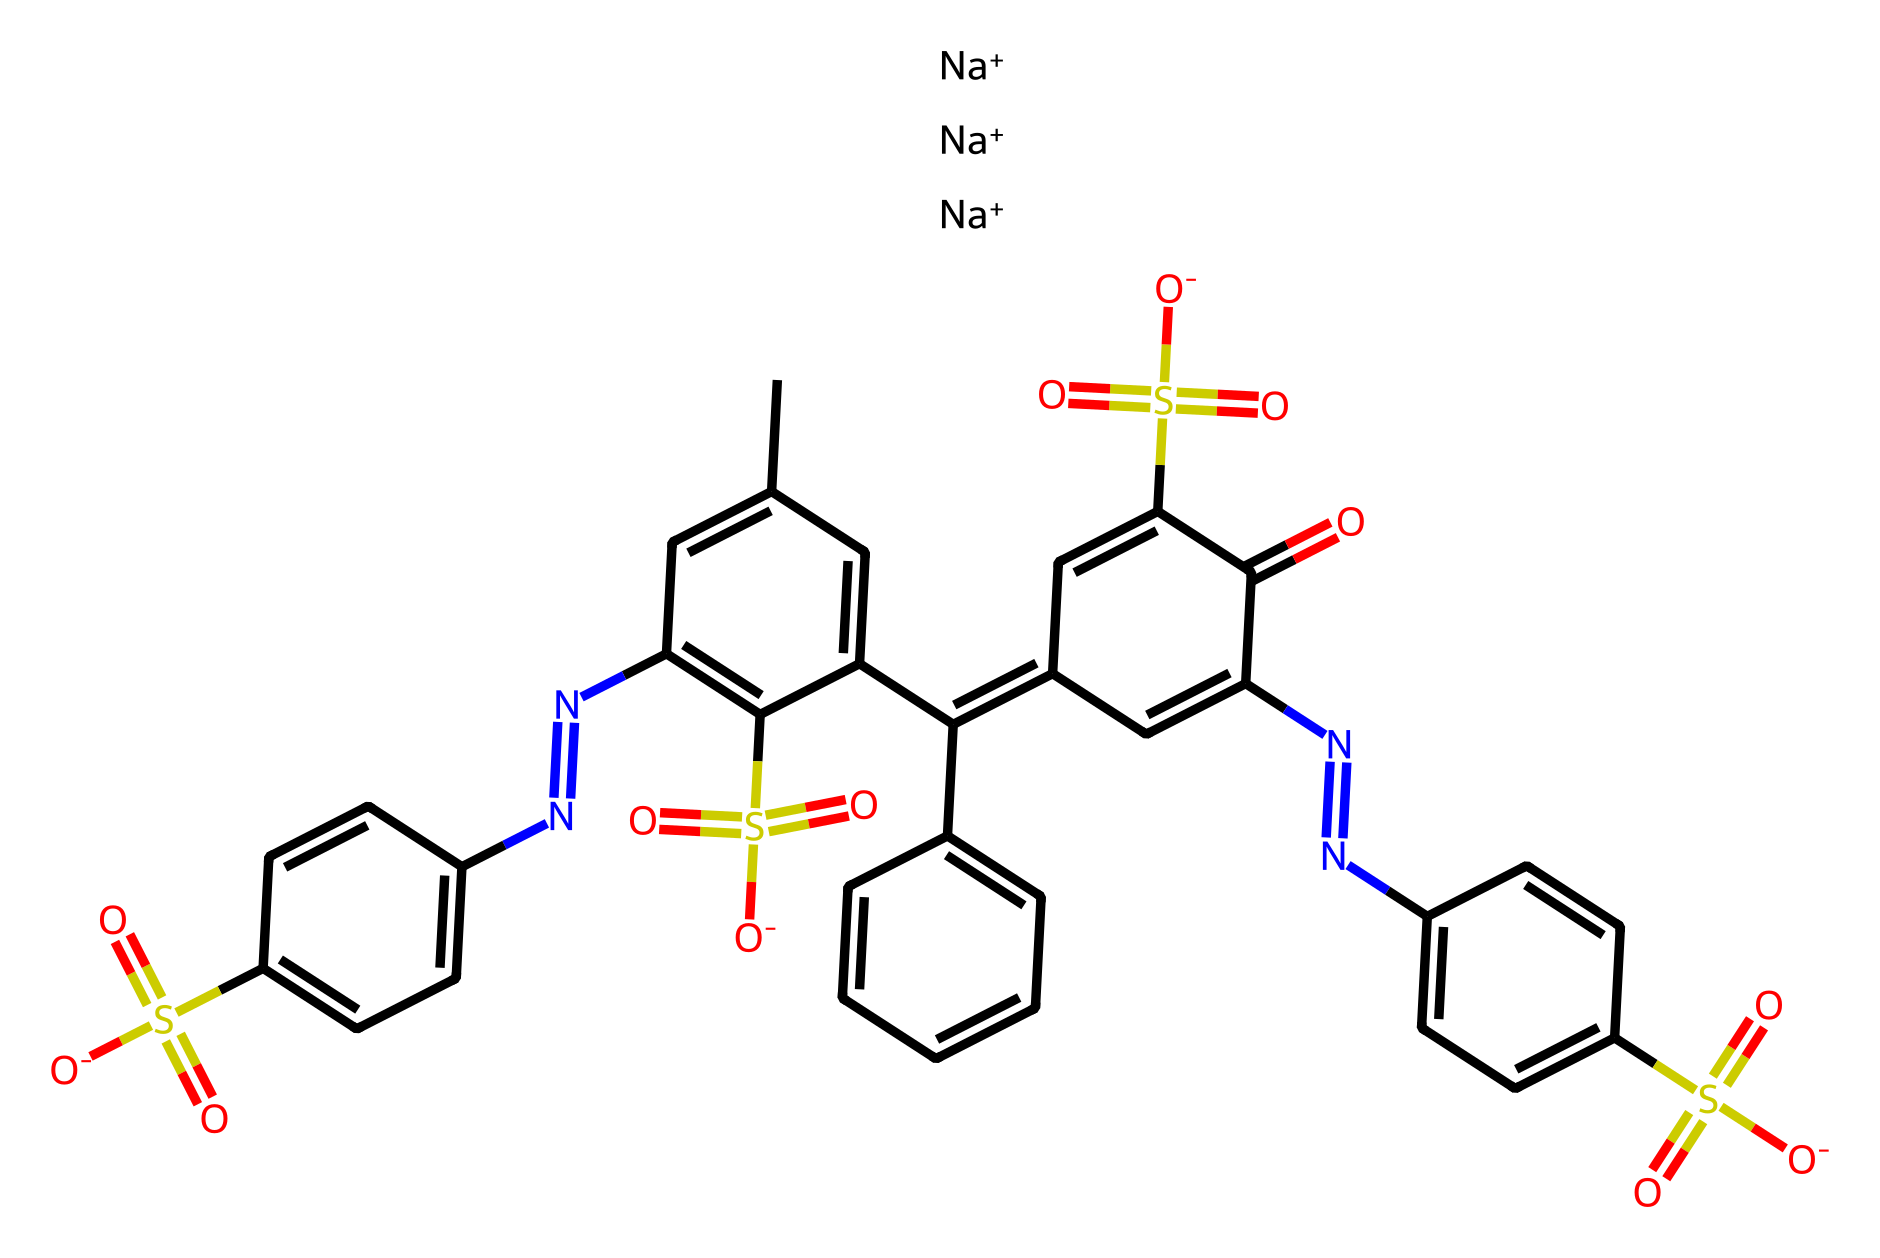What is the molecular formula of this dye? To determine the molecular formula, count the number of each type of atom present in the chemical structure represented by the SMILES. Here, we see multiple carbon (C), nitrogen (N), sulfur (S), oxygen (O), and sodium (Na) atoms. Counting yields: C 30, H 28, N 4, O 7, S 4, and Na 3. Thus, the molecular formula is C30H28N4O7S4Na3.
Answer: C30H28N4O7S4Na3 How many nitrogen atoms are present in the chemical? In the provided SMILES structure, we identify the nitrogen (N) atoms by counting every occurrence of the nitrogen symbol. There are four instances of nitrogen in the structure.
Answer: 4 What type of dye is represented by this chemical? The structure indicates that it has a complex arrangement of multiple benzene rings and contains sulfonic acid groups (-SO3H), characterizing it as an azo dye. Azo dyes are noted for their vivid colors used in printing and textiles.
Answer: azo dye How many sulfonic acid groups are in this dye? By analyzing the chemical structure, we look for the -SO3H groups or their deprotonated form -SO3-. There are four instances of sulfonic acid groups represented in the SMILES code.
Answer: 4 What is the primary color usually associated with this type of dye? Azo dyes are known for producing a variety of colors, but many are prominently red, especially those similar to the structure presented. The specific presence of aromatic and sulfonate groups suggests a bright red hue commonly associated with many azo dyes.
Answer: red 